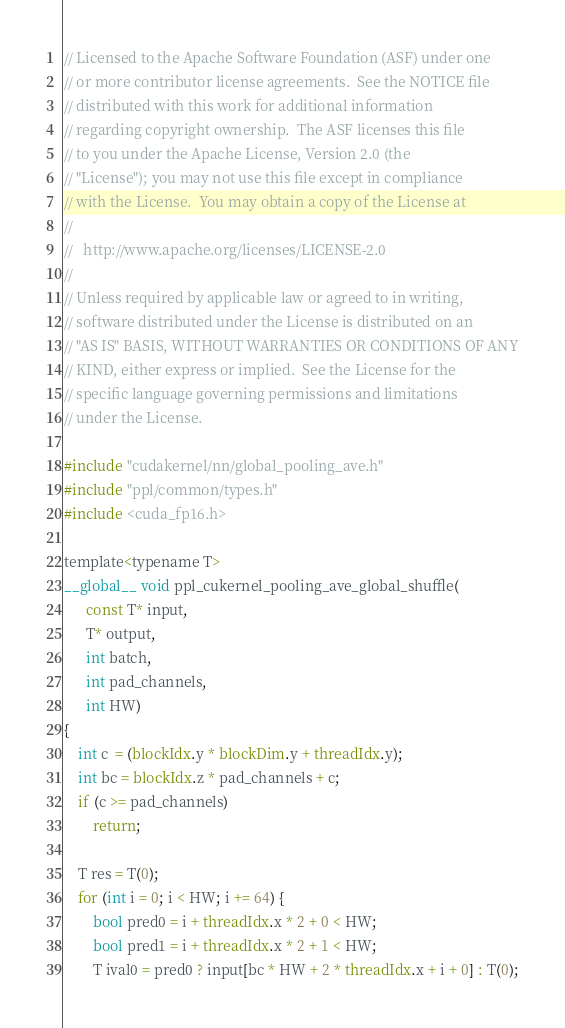Convert code to text. <code><loc_0><loc_0><loc_500><loc_500><_Cuda_>// Licensed to the Apache Software Foundation (ASF) under one
// or more contributor license agreements.  See the NOTICE file
// distributed with this work for additional information
// regarding copyright ownership.  The ASF licenses this file
// to you under the Apache License, Version 2.0 (the
// "License"); you may not use this file except in compliance
// with the License.  You may obtain a copy of the License at
//
//   http://www.apache.org/licenses/LICENSE-2.0
//
// Unless required by applicable law or agreed to in writing,
// software distributed under the License is distributed on an
// "AS IS" BASIS, WITHOUT WARRANTIES OR CONDITIONS OF ANY
// KIND, either express or implied.  See the License for the
// specific language governing permissions and limitations
// under the License.

#include "cudakernel/nn/global_pooling_ave.h"
#include "ppl/common/types.h"
#include <cuda_fp16.h>

template<typename T>
__global__ void ppl_cukernel_pooling_ave_global_shuffle(
      const T* input,
      T* output,
      int batch,
      int pad_channels,
      int HW)
{
    int c  = (blockIdx.y * blockDim.y + threadIdx.y);
    int bc = blockIdx.z * pad_channels + c;
    if (c >= pad_channels)
        return;

    T res = T(0);
    for (int i = 0; i < HW; i += 64) {
        bool pred0 = i + threadIdx.x * 2 + 0 < HW;
        bool pred1 = i + threadIdx.x * 2 + 1 < HW;
        T ival0 = pred0 ? input[bc * HW + 2 * threadIdx.x + i + 0] : T(0);</code> 